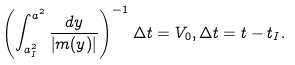Convert formula to latex. <formula><loc_0><loc_0><loc_500><loc_500>\left ( \int _ { a _ { I } ^ { 2 } } ^ { a ^ { 2 } } \frac { d y } { \left | m ( y ) \right | } \right ) ^ { - 1 } \Delta t = V _ { 0 } , \Delta t = t - t _ { I } .</formula> 